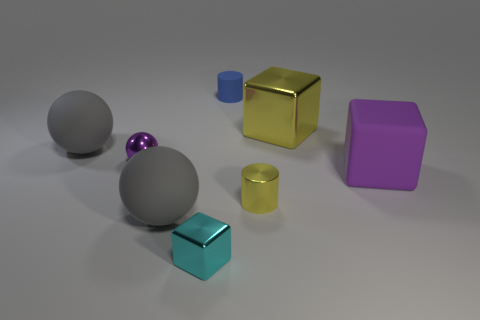Add 1 small red spheres. How many objects exist? 9 Subtract all cylinders. How many objects are left? 6 Add 1 big yellow metallic objects. How many big yellow metallic objects are left? 2 Add 5 cubes. How many cubes exist? 8 Subtract 0 blue cubes. How many objects are left? 8 Subtract all tiny purple metal objects. Subtract all small purple spheres. How many objects are left? 6 